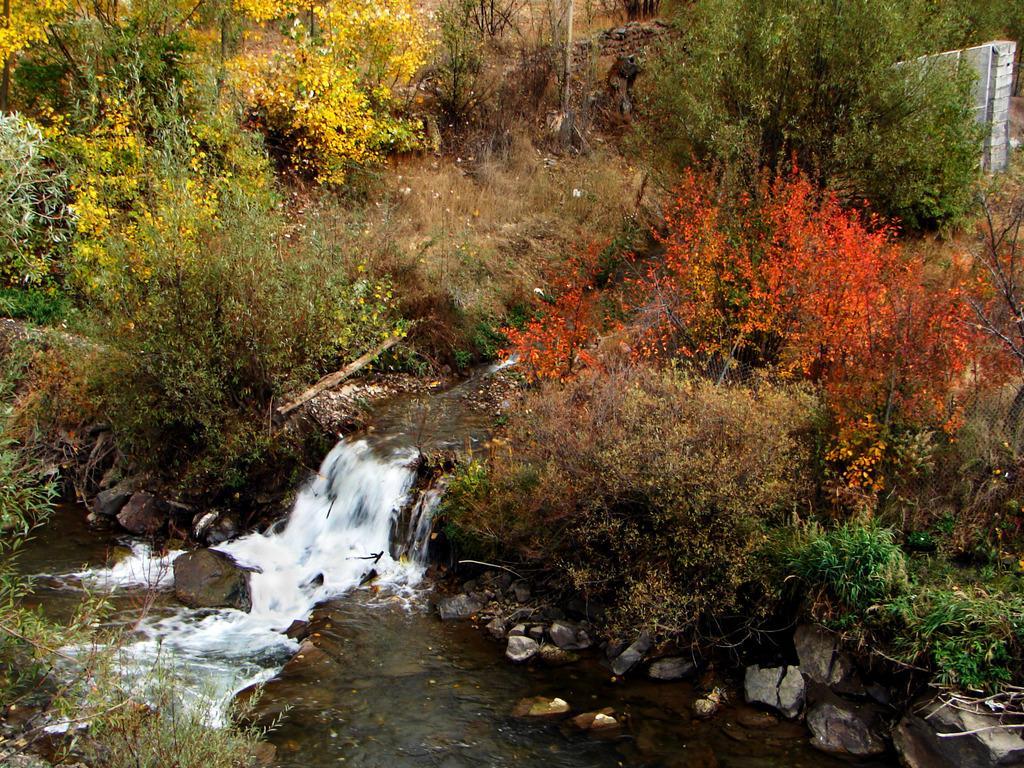Can you describe this image briefly? In this image I can see water and few stones. Background I can see few flowers in orange and yellow color, and plants in green color. 